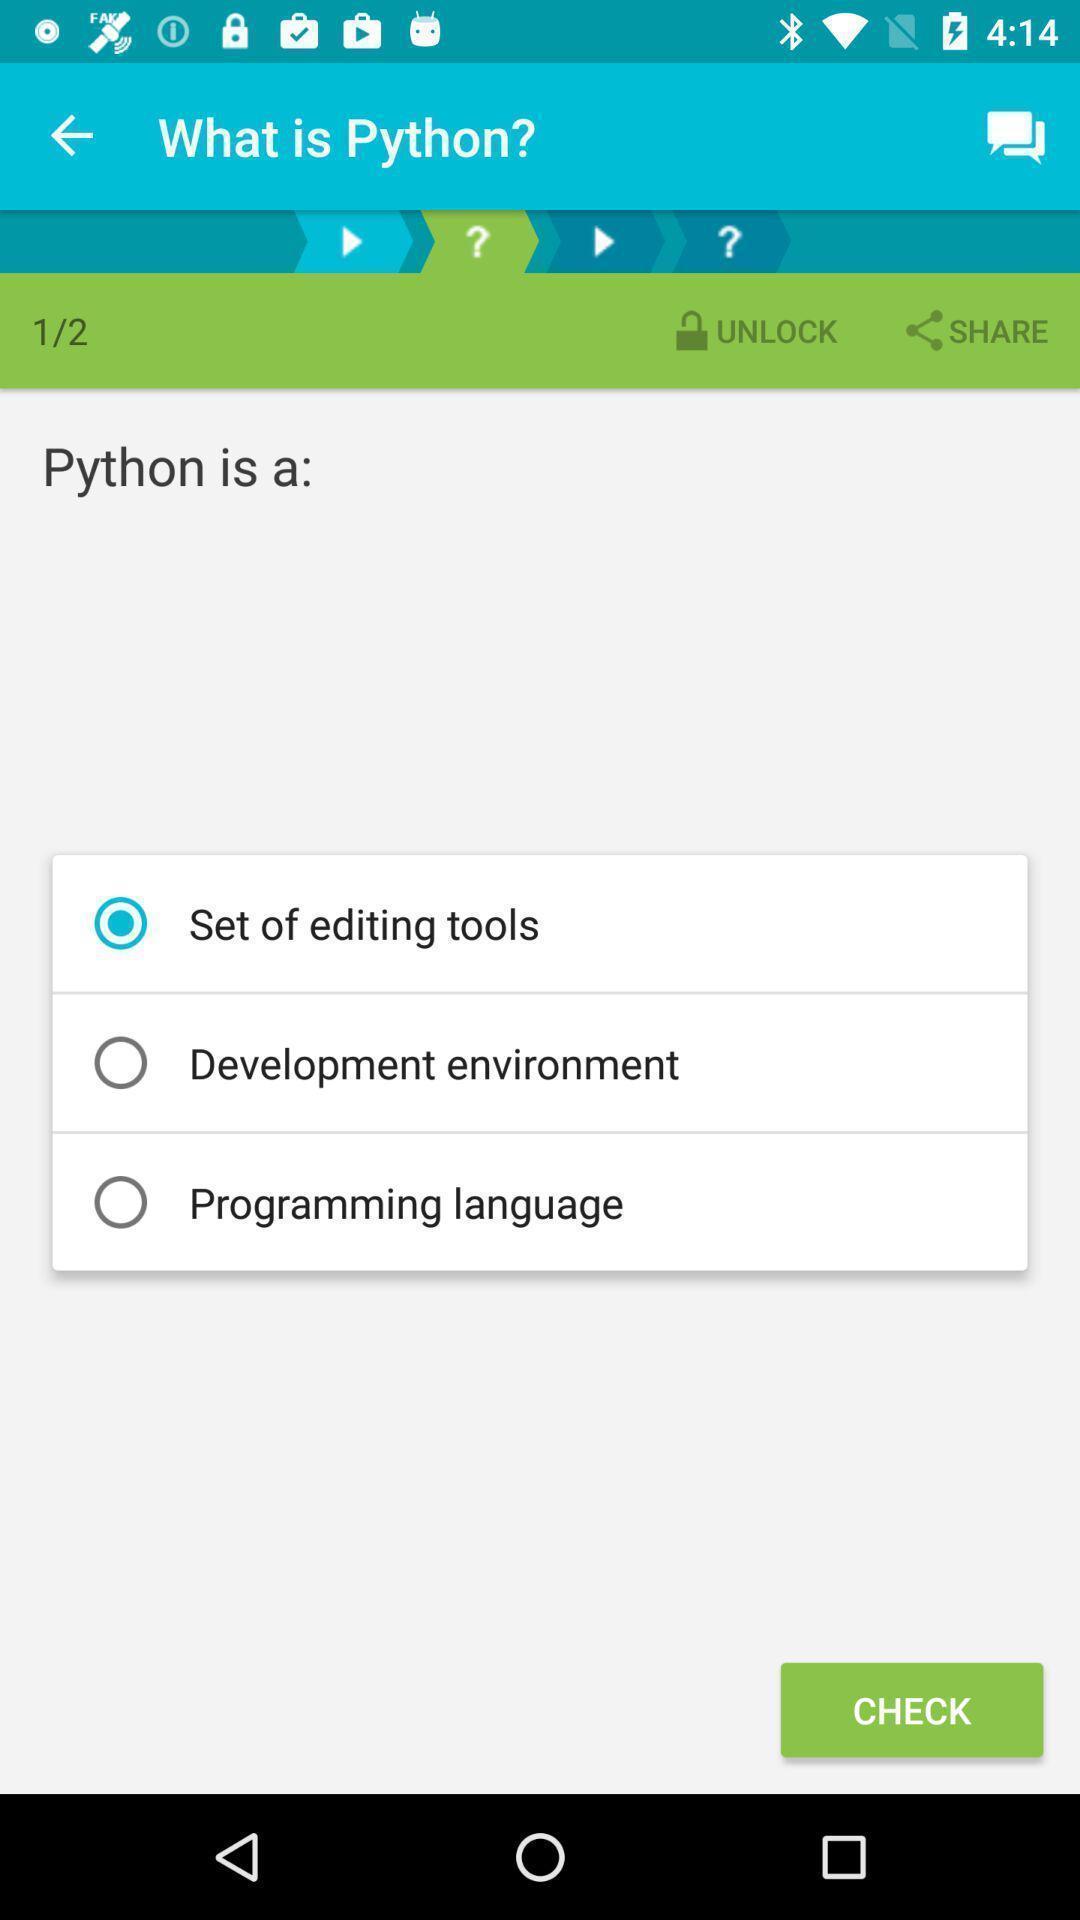Describe this image in words. Page showing options in leaning app. 